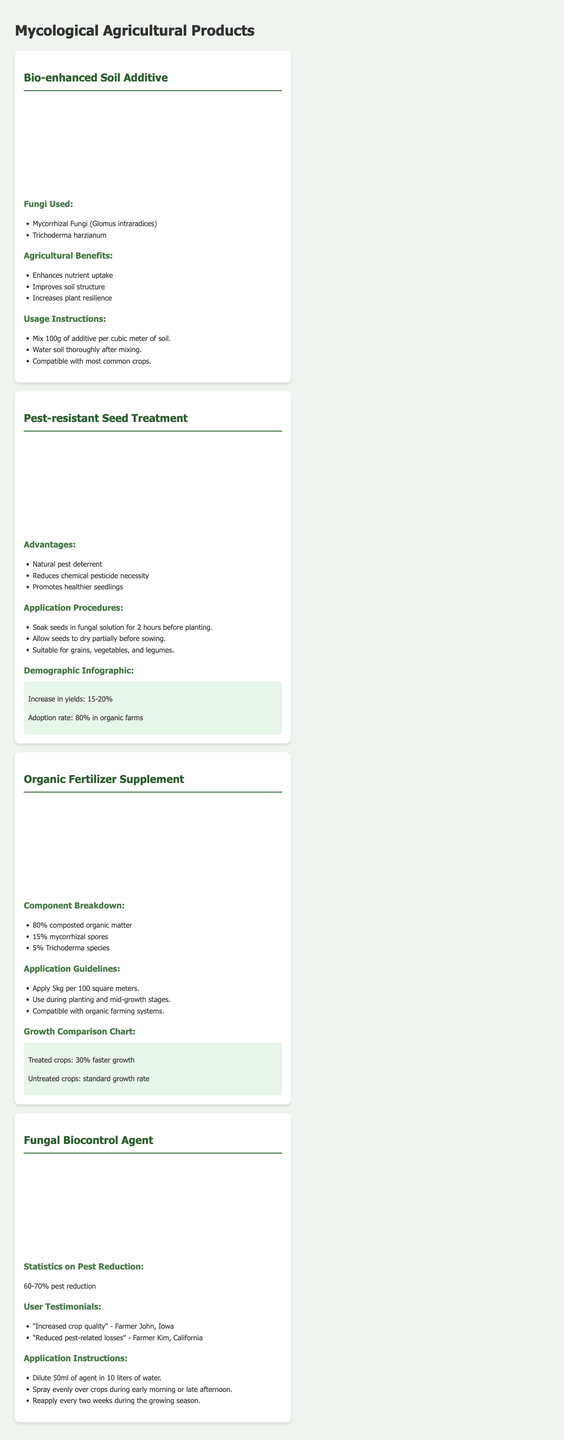what types of fungi are used in the Bio-enhanced Soil Additive? The document lists the types of fungi used in this product, which are Mycorrhizal Fungi (Glomus intraradices) and Trichoderma harzianum.
Answer: Mycorrhizal Fungi (Glomus intraradices), Trichoderma harzianum how much of the Soil Additive should be mixed per cubic meter of soil? The usage instructions for the Bio-enhanced Soil Additive specify that 100g of additive should be mixed per cubic meter of soil.
Answer: 100g what is the increase in yields according to the Pest-resistant Seed Treatment infographic? The infographic on the Pest-resistant Seed Treatment indicates an increase in yields of 15-20%.
Answer: 15-20% how often should the Fungal Biocontrol Agent be reapplied during the growing season? The application instructions state that the Fungal Biocontrol Agent should be reapplied every two weeks.
Answer: every two weeks what percentage of composted organic matter is in the Organic Fertilizer Supplement? The component breakdown of the Organic Fertilizer Supplement reveals that it contains 80% composted organic matter.
Answer: 80% what is the percentage reduction of pests when using the Fungal Biocontrol Agent? The statistics on pest reduction for the Fungal Biocontrol Agent indicate a 60-70% reduction.
Answer: 60-70% which demographic has an 80% adoption rate for the Pest-resistant Seed Treatment? The document states that the adoption rate is 80% in organic farms.
Answer: organic farms what are the application guidelines for the Organic Fertilizer Supplement? The application guidelines detail that 5kg should be applied per 100 square meters and during planting and mid-growth stages.
Answer: 5kg per 100 square meters 